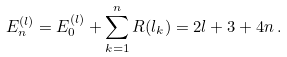Convert formula to latex. <formula><loc_0><loc_0><loc_500><loc_500>E _ { n } ^ { ( l ) } = E _ { 0 } ^ { ( l ) } + \sum _ { k = 1 } ^ { n } R ( l _ { k } ) = 2 l + 3 + 4 n \, .</formula> 